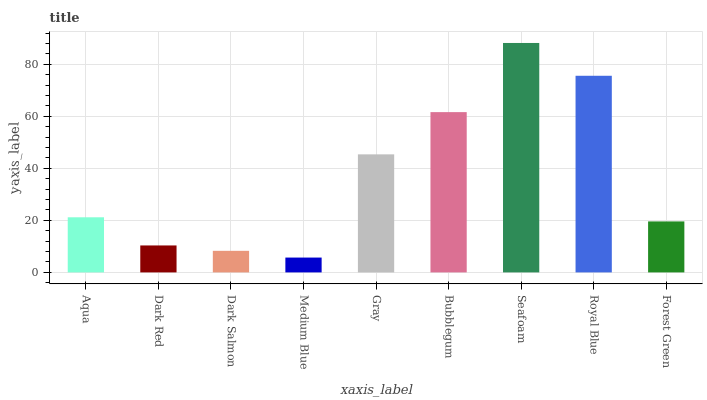Is Medium Blue the minimum?
Answer yes or no. Yes. Is Seafoam the maximum?
Answer yes or no. Yes. Is Dark Red the minimum?
Answer yes or no. No. Is Dark Red the maximum?
Answer yes or no. No. Is Aqua greater than Dark Red?
Answer yes or no. Yes. Is Dark Red less than Aqua?
Answer yes or no. Yes. Is Dark Red greater than Aqua?
Answer yes or no. No. Is Aqua less than Dark Red?
Answer yes or no. No. Is Aqua the high median?
Answer yes or no. Yes. Is Aqua the low median?
Answer yes or no. Yes. Is Bubblegum the high median?
Answer yes or no. No. Is Royal Blue the low median?
Answer yes or no. No. 